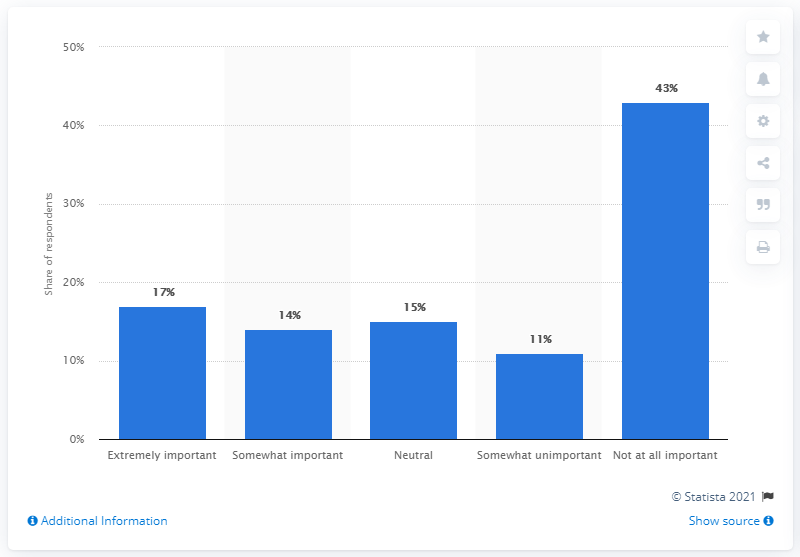Give some essential details in this illustration. According to the data provided, 43% of respondents rate athlete/celebrity sponsorship as not important to their decision-making process. 